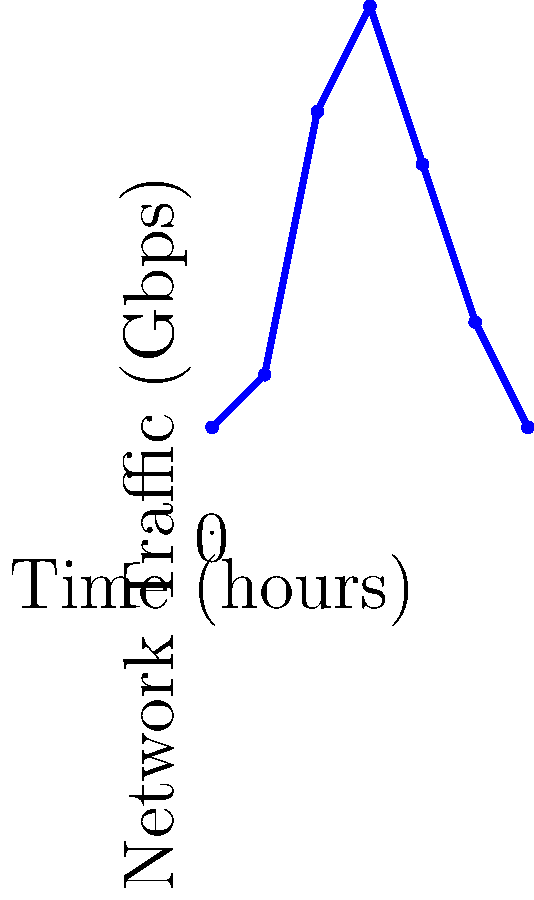During President Obama's televised speech, network traffic spiked significantly. Based on the graph, what was the approximate peak network traffic in Gbps during the speech? To determine the peak network traffic during President Obama's speech, let's analyze the graph step-by-step:

1. The x-axis represents time in hours, and the y-axis represents network traffic in Gbps.
2. The speech starts at the 2-hour mark and ends at the 4-hour mark, as indicated by the labels.
3. During this period, we observe a sharp increase in network traffic.
4. The traffic rises from about 3 Gbps before the speech to a peak at the 3-hour mark.
5. At this peak, the graph reaches its highest point on the y-axis.
6. By examining the y-axis, we can see that this peak is very close to the 10 Gbps mark.

Therefore, the approximate peak network traffic during President Obama's speech was 10 Gbps.
Answer: 10 Gbps 